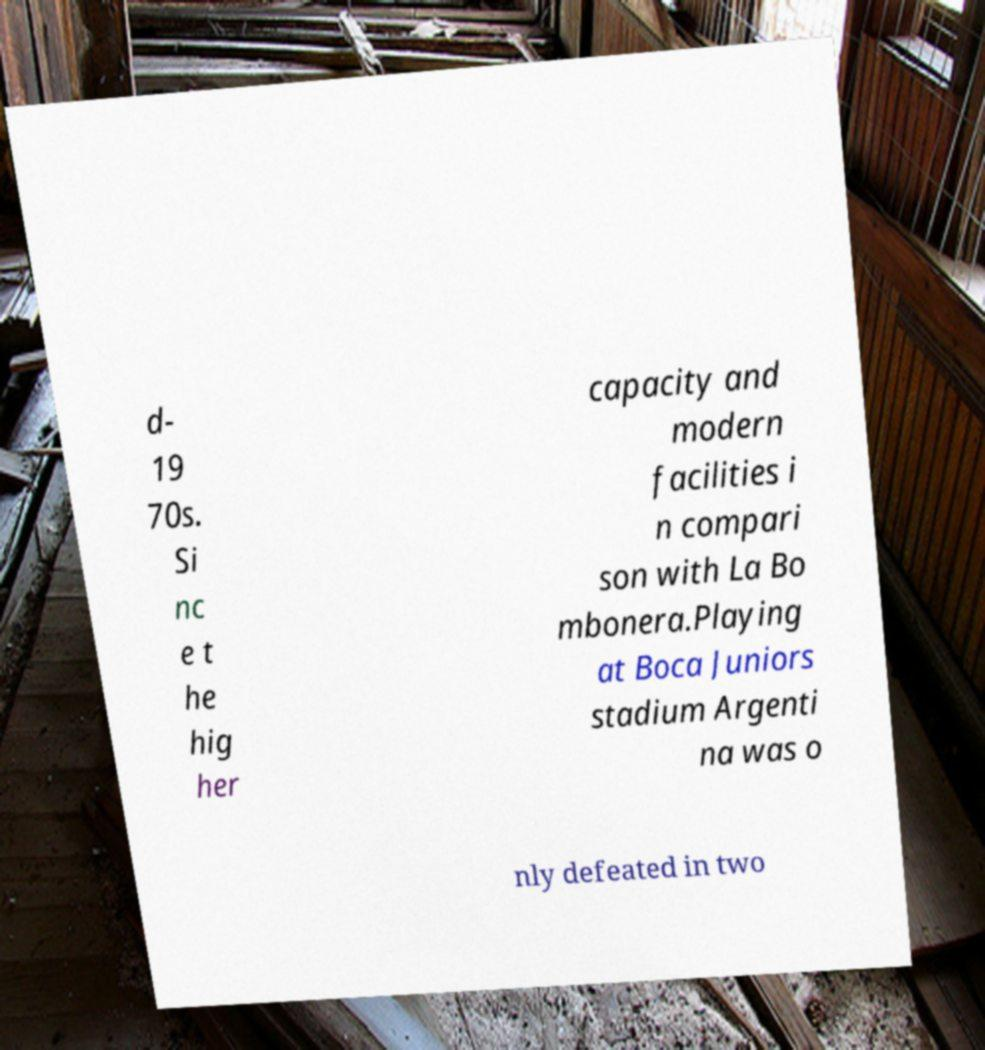What messages or text are displayed in this image? I need them in a readable, typed format. d- 19 70s. Si nc e t he hig her capacity and modern facilities i n compari son with La Bo mbonera.Playing at Boca Juniors stadium Argenti na was o nly defeated in two 